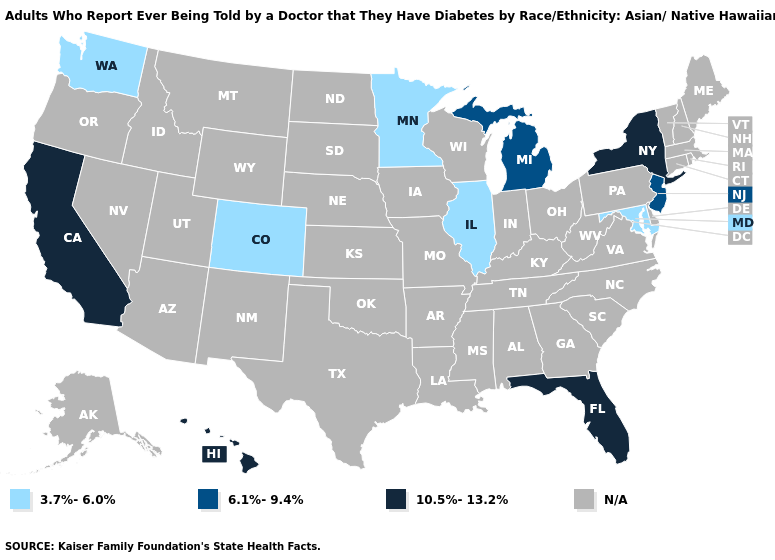Name the states that have a value in the range 10.5%-13.2%?
Be succinct. California, Florida, Hawaii, New York. What is the value of Louisiana?
Be succinct. N/A. What is the value of Louisiana?
Be succinct. N/A. Which states hav the highest value in the MidWest?
Write a very short answer. Michigan. Which states hav the highest value in the West?
Be succinct. California, Hawaii. Does the first symbol in the legend represent the smallest category?
Write a very short answer. Yes. What is the highest value in the USA?
Give a very brief answer. 10.5%-13.2%. Name the states that have a value in the range 3.7%-6.0%?
Short answer required. Colorado, Illinois, Maryland, Minnesota, Washington. What is the value of Illinois?
Keep it brief. 3.7%-6.0%. Which states have the lowest value in the MidWest?
Write a very short answer. Illinois, Minnesota. What is the value of California?
Quick response, please. 10.5%-13.2%. What is the value of Colorado?
Answer briefly. 3.7%-6.0%. Is the legend a continuous bar?
Short answer required. No. What is the value of Nevada?
Short answer required. N/A. 